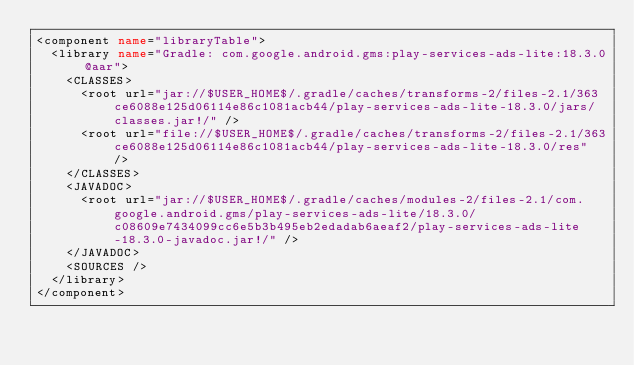Convert code to text. <code><loc_0><loc_0><loc_500><loc_500><_XML_><component name="libraryTable">
  <library name="Gradle: com.google.android.gms:play-services-ads-lite:18.3.0@aar">
    <CLASSES>
      <root url="jar://$USER_HOME$/.gradle/caches/transforms-2/files-2.1/363ce6088e125d06114e86c1081acb44/play-services-ads-lite-18.3.0/jars/classes.jar!/" />
      <root url="file://$USER_HOME$/.gradle/caches/transforms-2/files-2.1/363ce6088e125d06114e86c1081acb44/play-services-ads-lite-18.3.0/res" />
    </CLASSES>
    <JAVADOC>
      <root url="jar://$USER_HOME$/.gradle/caches/modules-2/files-2.1/com.google.android.gms/play-services-ads-lite/18.3.0/c08609e7434099cc6e5b3b495eb2edadab6aeaf2/play-services-ads-lite-18.3.0-javadoc.jar!/" />
    </JAVADOC>
    <SOURCES />
  </library>
</component></code> 